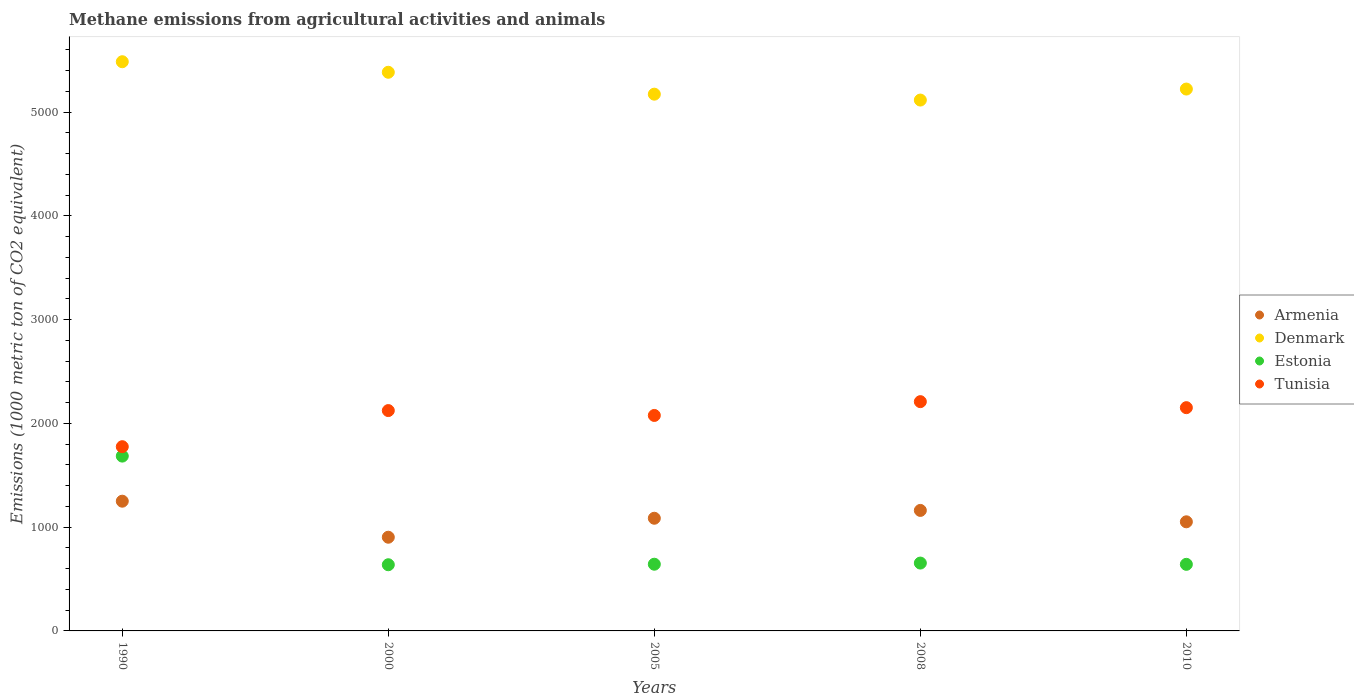How many different coloured dotlines are there?
Give a very brief answer. 4. What is the amount of methane emitted in Estonia in 2005?
Your answer should be very brief. 642.9. Across all years, what is the maximum amount of methane emitted in Armenia?
Your answer should be compact. 1250.4. Across all years, what is the minimum amount of methane emitted in Denmark?
Make the answer very short. 5116.7. What is the total amount of methane emitted in Denmark in the graph?
Provide a short and direct response. 2.64e+04. What is the difference between the amount of methane emitted in Denmark in 1990 and that in 2008?
Keep it short and to the point. 369.5. What is the difference between the amount of methane emitted in Tunisia in 1990 and the amount of methane emitted in Armenia in 2005?
Make the answer very short. 689.7. What is the average amount of methane emitted in Armenia per year?
Keep it short and to the point. 1090.54. In the year 2008, what is the difference between the amount of methane emitted in Armenia and amount of methane emitted in Tunisia?
Your answer should be compact. -1048.3. What is the ratio of the amount of methane emitted in Tunisia in 1990 to that in 2000?
Keep it short and to the point. 0.84. Is the amount of methane emitted in Estonia in 1990 less than that in 2000?
Keep it short and to the point. No. What is the difference between the highest and the second highest amount of methane emitted in Estonia?
Make the answer very short. 1031. What is the difference between the highest and the lowest amount of methane emitted in Estonia?
Give a very brief answer. 1047.1. Is the sum of the amount of methane emitted in Estonia in 2000 and 2008 greater than the maximum amount of methane emitted in Armenia across all years?
Your response must be concise. Yes. Does the amount of methane emitted in Tunisia monotonically increase over the years?
Ensure brevity in your answer.  No. Is the amount of methane emitted in Armenia strictly less than the amount of methane emitted in Estonia over the years?
Your answer should be compact. No. How many dotlines are there?
Your answer should be very brief. 4. What is the difference between two consecutive major ticks on the Y-axis?
Keep it short and to the point. 1000. Does the graph contain any zero values?
Make the answer very short. No. Where does the legend appear in the graph?
Offer a terse response. Center right. What is the title of the graph?
Your answer should be very brief. Methane emissions from agricultural activities and animals. What is the label or title of the Y-axis?
Your response must be concise. Emissions (1000 metric ton of CO2 equivalent). What is the Emissions (1000 metric ton of CO2 equivalent) in Armenia in 1990?
Your response must be concise. 1250.4. What is the Emissions (1000 metric ton of CO2 equivalent) in Denmark in 1990?
Provide a short and direct response. 5486.2. What is the Emissions (1000 metric ton of CO2 equivalent) of Estonia in 1990?
Your response must be concise. 1685. What is the Emissions (1000 metric ton of CO2 equivalent) in Tunisia in 1990?
Offer a terse response. 1775.7. What is the Emissions (1000 metric ton of CO2 equivalent) of Armenia in 2000?
Keep it short and to the point. 903.1. What is the Emissions (1000 metric ton of CO2 equivalent) of Denmark in 2000?
Your response must be concise. 5384.6. What is the Emissions (1000 metric ton of CO2 equivalent) in Estonia in 2000?
Your answer should be very brief. 637.9. What is the Emissions (1000 metric ton of CO2 equivalent) in Tunisia in 2000?
Your answer should be very brief. 2123.8. What is the Emissions (1000 metric ton of CO2 equivalent) of Armenia in 2005?
Keep it short and to the point. 1086. What is the Emissions (1000 metric ton of CO2 equivalent) in Denmark in 2005?
Offer a very short reply. 5173.5. What is the Emissions (1000 metric ton of CO2 equivalent) in Estonia in 2005?
Your answer should be very brief. 642.9. What is the Emissions (1000 metric ton of CO2 equivalent) in Tunisia in 2005?
Keep it short and to the point. 2076.8. What is the Emissions (1000 metric ton of CO2 equivalent) of Armenia in 2008?
Offer a terse response. 1161.5. What is the Emissions (1000 metric ton of CO2 equivalent) of Denmark in 2008?
Ensure brevity in your answer.  5116.7. What is the Emissions (1000 metric ton of CO2 equivalent) of Estonia in 2008?
Make the answer very short. 654. What is the Emissions (1000 metric ton of CO2 equivalent) in Tunisia in 2008?
Your response must be concise. 2209.8. What is the Emissions (1000 metric ton of CO2 equivalent) of Armenia in 2010?
Your answer should be compact. 1051.7. What is the Emissions (1000 metric ton of CO2 equivalent) in Denmark in 2010?
Provide a short and direct response. 5222.8. What is the Emissions (1000 metric ton of CO2 equivalent) of Estonia in 2010?
Your answer should be compact. 641.8. What is the Emissions (1000 metric ton of CO2 equivalent) in Tunisia in 2010?
Offer a terse response. 2151.9. Across all years, what is the maximum Emissions (1000 metric ton of CO2 equivalent) of Armenia?
Offer a very short reply. 1250.4. Across all years, what is the maximum Emissions (1000 metric ton of CO2 equivalent) in Denmark?
Your answer should be very brief. 5486.2. Across all years, what is the maximum Emissions (1000 metric ton of CO2 equivalent) of Estonia?
Your response must be concise. 1685. Across all years, what is the maximum Emissions (1000 metric ton of CO2 equivalent) of Tunisia?
Offer a very short reply. 2209.8. Across all years, what is the minimum Emissions (1000 metric ton of CO2 equivalent) in Armenia?
Your answer should be very brief. 903.1. Across all years, what is the minimum Emissions (1000 metric ton of CO2 equivalent) in Denmark?
Your answer should be very brief. 5116.7. Across all years, what is the minimum Emissions (1000 metric ton of CO2 equivalent) of Estonia?
Give a very brief answer. 637.9. Across all years, what is the minimum Emissions (1000 metric ton of CO2 equivalent) in Tunisia?
Your answer should be compact. 1775.7. What is the total Emissions (1000 metric ton of CO2 equivalent) of Armenia in the graph?
Give a very brief answer. 5452.7. What is the total Emissions (1000 metric ton of CO2 equivalent) in Denmark in the graph?
Your answer should be compact. 2.64e+04. What is the total Emissions (1000 metric ton of CO2 equivalent) of Estonia in the graph?
Your response must be concise. 4261.6. What is the total Emissions (1000 metric ton of CO2 equivalent) in Tunisia in the graph?
Offer a terse response. 1.03e+04. What is the difference between the Emissions (1000 metric ton of CO2 equivalent) of Armenia in 1990 and that in 2000?
Offer a terse response. 347.3. What is the difference between the Emissions (1000 metric ton of CO2 equivalent) of Denmark in 1990 and that in 2000?
Provide a succinct answer. 101.6. What is the difference between the Emissions (1000 metric ton of CO2 equivalent) of Estonia in 1990 and that in 2000?
Provide a succinct answer. 1047.1. What is the difference between the Emissions (1000 metric ton of CO2 equivalent) of Tunisia in 1990 and that in 2000?
Your answer should be compact. -348.1. What is the difference between the Emissions (1000 metric ton of CO2 equivalent) of Armenia in 1990 and that in 2005?
Make the answer very short. 164.4. What is the difference between the Emissions (1000 metric ton of CO2 equivalent) of Denmark in 1990 and that in 2005?
Keep it short and to the point. 312.7. What is the difference between the Emissions (1000 metric ton of CO2 equivalent) in Estonia in 1990 and that in 2005?
Make the answer very short. 1042.1. What is the difference between the Emissions (1000 metric ton of CO2 equivalent) of Tunisia in 1990 and that in 2005?
Offer a terse response. -301.1. What is the difference between the Emissions (1000 metric ton of CO2 equivalent) in Armenia in 1990 and that in 2008?
Ensure brevity in your answer.  88.9. What is the difference between the Emissions (1000 metric ton of CO2 equivalent) in Denmark in 1990 and that in 2008?
Your answer should be very brief. 369.5. What is the difference between the Emissions (1000 metric ton of CO2 equivalent) in Estonia in 1990 and that in 2008?
Provide a succinct answer. 1031. What is the difference between the Emissions (1000 metric ton of CO2 equivalent) of Tunisia in 1990 and that in 2008?
Give a very brief answer. -434.1. What is the difference between the Emissions (1000 metric ton of CO2 equivalent) of Armenia in 1990 and that in 2010?
Provide a succinct answer. 198.7. What is the difference between the Emissions (1000 metric ton of CO2 equivalent) of Denmark in 1990 and that in 2010?
Offer a terse response. 263.4. What is the difference between the Emissions (1000 metric ton of CO2 equivalent) of Estonia in 1990 and that in 2010?
Ensure brevity in your answer.  1043.2. What is the difference between the Emissions (1000 metric ton of CO2 equivalent) in Tunisia in 1990 and that in 2010?
Your response must be concise. -376.2. What is the difference between the Emissions (1000 metric ton of CO2 equivalent) of Armenia in 2000 and that in 2005?
Provide a succinct answer. -182.9. What is the difference between the Emissions (1000 metric ton of CO2 equivalent) of Denmark in 2000 and that in 2005?
Make the answer very short. 211.1. What is the difference between the Emissions (1000 metric ton of CO2 equivalent) of Estonia in 2000 and that in 2005?
Keep it short and to the point. -5. What is the difference between the Emissions (1000 metric ton of CO2 equivalent) of Armenia in 2000 and that in 2008?
Provide a short and direct response. -258.4. What is the difference between the Emissions (1000 metric ton of CO2 equivalent) in Denmark in 2000 and that in 2008?
Your answer should be very brief. 267.9. What is the difference between the Emissions (1000 metric ton of CO2 equivalent) of Estonia in 2000 and that in 2008?
Your response must be concise. -16.1. What is the difference between the Emissions (1000 metric ton of CO2 equivalent) of Tunisia in 2000 and that in 2008?
Make the answer very short. -86. What is the difference between the Emissions (1000 metric ton of CO2 equivalent) of Armenia in 2000 and that in 2010?
Give a very brief answer. -148.6. What is the difference between the Emissions (1000 metric ton of CO2 equivalent) in Denmark in 2000 and that in 2010?
Make the answer very short. 161.8. What is the difference between the Emissions (1000 metric ton of CO2 equivalent) in Tunisia in 2000 and that in 2010?
Offer a terse response. -28.1. What is the difference between the Emissions (1000 metric ton of CO2 equivalent) of Armenia in 2005 and that in 2008?
Offer a very short reply. -75.5. What is the difference between the Emissions (1000 metric ton of CO2 equivalent) of Denmark in 2005 and that in 2008?
Offer a very short reply. 56.8. What is the difference between the Emissions (1000 metric ton of CO2 equivalent) of Tunisia in 2005 and that in 2008?
Your answer should be very brief. -133. What is the difference between the Emissions (1000 metric ton of CO2 equivalent) in Armenia in 2005 and that in 2010?
Give a very brief answer. 34.3. What is the difference between the Emissions (1000 metric ton of CO2 equivalent) of Denmark in 2005 and that in 2010?
Your answer should be compact. -49.3. What is the difference between the Emissions (1000 metric ton of CO2 equivalent) of Estonia in 2005 and that in 2010?
Your answer should be very brief. 1.1. What is the difference between the Emissions (1000 metric ton of CO2 equivalent) of Tunisia in 2005 and that in 2010?
Give a very brief answer. -75.1. What is the difference between the Emissions (1000 metric ton of CO2 equivalent) of Armenia in 2008 and that in 2010?
Your answer should be very brief. 109.8. What is the difference between the Emissions (1000 metric ton of CO2 equivalent) of Denmark in 2008 and that in 2010?
Your answer should be very brief. -106.1. What is the difference between the Emissions (1000 metric ton of CO2 equivalent) in Tunisia in 2008 and that in 2010?
Ensure brevity in your answer.  57.9. What is the difference between the Emissions (1000 metric ton of CO2 equivalent) in Armenia in 1990 and the Emissions (1000 metric ton of CO2 equivalent) in Denmark in 2000?
Your response must be concise. -4134.2. What is the difference between the Emissions (1000 metric ton of CO2 equivalent) in Armenia in 1990 and the Emissions (1000 metric ton of CO2 equivalent) in Estonia in 2000?
Make the answer very short. 612.5. What is the difference between the Emissions (1000 metric ton of CO2 equivalent) of Armenia in 1990 and the Emissions (1000 metric ton of CO2 equivalent) of Tunisia in 2000?
Your answer should be very brief. -873.4. What is the difference between the Emissions (1000 metric ton of CO2 equivalent) of Denmark in 1990 and the Emissions (1000 metric ton of CO2 equivalent) of Estonia in 2000?
Provide a short and direct response. 4848.3. What is the difference between the Emissions (1000 metric ton of CO2 equivalent) of Denmark in 1990 and the Emissions (1000 metric ton of CO2 equivalent) of Tunisia in 2000?
Provide a short and direct response. 3362.4. What is the difference between the Emissions (1000 metric ton of CO2 equivalent) of Estonia in 1990 and the Emissions (1000 metric ton of CO2 equivalent) of Tunisia in 2000?
Your answer should be very brief. -438.8. What is the difference between the Emissions (1000 metric ton of CO2 equivalent) in Armenia in 1990 and the Emissions (1000 metric ton of CO2 equivalent) in Denmark in 2005?
Provide a short and direct response. -3923.1. What is the difference between the Emissions (1000 metric ton of CO2 equivalent) of Armenia in 1990 and the Emissions (1000 metric ton of CO2 equivalent) of Estonia in 2005?
Your answer should be very brief. 607.5. What is the difference between the Emissions (1000 metric ton of CO2 equivalent) of Armenia in 1990 and the Emissions (1000 metric ton of CO2 equivalent) of Tunisia in 2005?
Your response must be concise. -826.4. What is the difference between the Emissions (1000 metric ton of CO2 equivalent) in Denmark in 1990 and the Emissions (1000 metric ton of CO2 equivalent) in Estonia in 2005?
Give a very brief answer. 4843.3. What is the difference between the Emissions (1000 metric ton of CO2 equivalent) of Denmark in 1990 and the Emissions (1000 metric ton of CO2 equivalent) of Tunisia in 2005?
Offer a very short reply. 3409.4. What is the difference between the Emissions (1000 metric ton of CO2 equivalent) in Estonia in 1990 and the Emissions (1000 metric ton of CO2 equivalent) in Tunisia in 2005?
Your answer should be very brief. -391.8. What is the difference between the Emissions (1000 metric ton of CO2 equivalent) in Armenia in 1990 and the Emissions (1000 metric ton of CO2 equivalent) in Denmark in 2008?
Keep it short and to the point. -3866.3. What is the difference between the Emissions (1000 metric ton of CO2 equivalent) in Armenia in 1990 and the Emissions (1000 metric ton of CO2 equivalent) in Estonia in 2008?
Your answer should be compact. 596.4. What is the difference between the Emissions (1000 metric ton of CO2 equivalent) of Armenia in 1990 and the Emissions (1000 metric ton of CO2 equivalent) of Tunisia in 2008?
Provide a succinct answer. -959.4. What is the difference between the Emissions (1000 metric ton of CO2 equivalent) of Denmark in 1990 and the Emissions (1000 metric ton of CO2 equivalent) of Estonia in 2008?
Ensure brevity in your answer.  4832.2. What is the difference between the Emissions (1000 metric ton of CO2 equivalent) of Denmark in 1990 and the Emissions (1000 metric ton of CO2 equivalent) of Tunisia in 2008?
Provide a succinct answer. 3276.4. What is the difference between the Emissions (1000 metric ton of CO2 equivalent) in Estonia in 1990 and the Emissions (1000 metric ton of CO2 equivalent) in Tunisia in 2008?
Make the answer very short. -524.8. What is the difference between the Emissions (1000 metric ton of CO2 equivalent) in Armenia in 1990 and the Emissions (1000 metric ton of CO2 equivalent) in Denmark in 2010?
Make the answer very short. -3972.4. What is the difference between the Emissions (1000 metric ton of CO2 equivalent) in Armenia in 1990 and the Emissions (1000 metric ton of CO2 equivalent) in Estonia in 2010?
Your answer should be very brief. 608.6. What is the difference between the Emissions (1000 metric ton of CO2 equivalent) in Armenia in 1990 and the Emissions (1000 metric ton of CO2 equivalent) in Tunisia in 2010?
Provide a short and direct response. -901.5. What is the difference between the Emissions (1000 metric ton of CO2 equivalent) of Denmark in 1990 and the Emissions (1000 metric ton of CO2 equivalent) of Estonia in 2010?
Offer a terse response. 4844.4. What is the difference between the Emissions (1000 metric ton of CO2 equivalent) of Denmark in 1990 and the Emissions (1000 metric ton of CO2 equivalent) of Tunisia in 2010?
Your answer should be compact. 3334.3. What is the difference between the Emissions (1000 metric ton of CO2 equivalent) in Estonia in 1990 and the Emissions (1000 metric ton of CO2 equivalent) in Tunisia in 2010?
Make the answer very short. -466.9. What is the difference between the Emissions (1000 metric ton of CO2 equivalent) in Armenia in 2000 and the Emissions (1000 metric ton of CO2 equivalent) in Denmark in 2005?
Ensure brevity in your answer.  -4270.4. What is the difference between the Emissions (1000 metric ton of CO2 equivalent) in Armenia in 2000 and the Emissions (1000 metric ton of CO2 equivalent) in Estonia in 2005?
Make the answer very short. 260.2. What is the difference between the Emissions (1000 metric ton of CO2 equivalent) of Armenia in 2000 and the Emissions (1000 metric ton of CO2 equivalent) of Tunisia in 2005?
Your response must be concise. -1173.7. What is the difference between the Emissions (1000 metric ton of CO2 equivalent) of Denmark in 2000 and the Emissions (1000 metric ton of CO2 equivalent) of Estonia in 2005?
Your answer should be very brief. 4741.7. What is the difference between the Emissions (1000 metric ton of CO2 equivalent) of Denmark in 2000 and the Emissions (1000 metric ton of CO2 equivalent) of Tunisia in 2005?
Your answer should be compact. 3307.8. What is the difference between the Emissions (1000 metric ton of CO2 equivalent) of Estonia in 2000 and the Emissions (1000 metric ton of CO2 equivalent) of Tunisia in 2005?
Make the answer very short. -1438.9. What is the difference between the Emissions (1000 metric ton of CO2 equivalent) of Armenia in 2000 and the Emissions (1000 metric ton of CO2 equivalent) of Denmark in 2008?
Offer a very short reply. -4213.6. What is the difference between the Emissions (1000 metric ton of CO2 equivalent) in Armenia in 2000 and the Emissions (1000 metric ton of CO2 equivalent) in Estonia in 2008?
Offer a very short reply. 249.1. What is the difference between the Emissions (1000 metric ton of CO2 equivalent) of Armenia in 2000 and the Emissions (1000 metric ton of CO2 equivalent) of Tunisia in 2008?
Your response must be concise. -1306.7. What is the difference between the Emissions (1000 metric ton of CO2 equivalent) of Denmark in 2000 and the Emissions (1000 metric ton of CO2 equivalent) of Estonia in 2008?
Offer a terse response. 4730.6. What is the difference between the Emissions (1000 metric ton of CO2 equivalent) of Denmark in 2000 and the Emissions (1000 metric ton of CO2 equivalent) of Tunisia in 2008?
Ensure brevity in your answer.  3174.8. What is the difference between the Emissions (1000 metric ton of CO2 equivalent) of Estonia in 2000 and the Emissions (1000 metric ton of CO2 equivalent) of Tunisia in 2008?
Ensure brevity in your answer.  -1571.9. What is the difference between the Emissions (1000 metric ton of CO2 equivalent) in Armenia in 2000 and the Emissions (1000 metric ton of CO2 equivalent) in Denmark in 2010?
Ensure brevity in your answer.  -4319.7. What is the difference between the Emissions (1000 metric ton of CO2 equivalent) in Armenia in 2000 and the Emissions (1000 metric ton of CO2 equivalent) in Estonia in 2010?
Make the answer very short. 261.3. What is the difference between the Emissions (1000 metric ton of CO2 equivalent) of Armenia in 2000 and the Emissions (1000 metric ton of CO2 equivalent) of Tunisia in 2010?
Provide a succinct answer. -1248.8. What is the difference between the Emissions (1000 metric ton of CO2 equivalent) of Denmark in 2000 and the Emissions (1000 metric ton of CO2 equivalent) of Estonia in 2010?
Make the answer very short. 4742.8. What is the difference between the Emissions (1000 metric ton of CO2 equivalent) in Denmark in 2000 and the Emissions (1000 metric ton of CO2 equivalent) in Tunisia in 2010?
Ensure brevity in your answer.  3232.7. What is the difference between the Emissions (1000 metric ton of CO2 equivalent) of Estonia in 2000 and the Emissions (1000 metric ton of CO2 equivalent) of Tunisia in 2010?
Provide a succinct answer. -1514. What is the difference between the Emissions (1000 metric ton of CO2 equivalent) of Armenia in 2005 and the Emissions (1000 metric ton of CO2 equivalent) of Denmark in 2008?
Ensure brevity in your answer.  -4030.7. What is the difference between the Emissions (1000 metric ton of CO2 equivalent) in Armenia in 2005 and the Emissions (1000 metric ton of CO2 equivalent) in Estonia in 2008?
Make the answer very short. 432. What is the difference between the Emissions (1000 metric ton of CO2 equivalent) in Armenia in 2005 and the Emissions (1000 metric ton of CO2 equivalent) in Tunisia in 2008?
Your answer should be compact. -1123.8. What is the difference between the Emissions (1000 metric ton of CO2 equivalent) in Denmark in 2005 and the Emissions (1000 metric ton of CO2 equivalent) in Estonia in 2008?
Your answer should be very brief. 4519.5. What is the difference between the Emissions (1000 metric ton of CO2 equivalent) in Denmark in 2005 and the Emissions (1000 metric ton of CO2 equivalent) in Tunisia in 2008?
Provide a short and direct response. 2963.7. What is the difference between the Emissions (1000 metric ton of CO2 equivalent) of Estonia in 2005 and the Emissions (1000 metric ton of CO2 equivalent) of Tunisia in 2008?
Ensure brevity in your answer.  -1566.9. What is the difference between the Emissions (1000 metric ton of CO2 equivalent) in Armenia in 2005 and the Emissions (1000 metric ton of CO2 equivalent) in Denmark in 2010?
Provide a succinct answer. -4136.8. What is the difference between the Emissions (1000 metric ton of CO2 equivalent) in Armenia in 2005 and the Emissions (1000 metric ton of CO2 equivalent) in Estonia in 2010?
Ensure brevity in your answer.  444.2. What is the difference between the Emissions (1000 metric ton of CO2 equivalent) in Armenia in 2005 and the Emissions (1000 metric ton of CO2 equivalent) in Tunisia in 2010?
Provide a succinct answer. -1065.9. What is the difference between the Emissions (1000 metric ton of CO2 equivalent) of Denmark in 2005 and the Emissions (1000 metric ton of CO2 equivalent) of Estonia in 2010?
Your answer should be very brief. 4531.7. What is the difference between the Emissions (1000 metric ton of CO2 equivalent) in Denmark in 2005 and the Emissions (1000 metric ton of CO2 equivalent) in Tunisia in 2010?
Provide a succinct answer. 3021.6. What is the difference between the Emissions (1000 metric ton of CO2 equivalent) of Estonia in 2005 and the Emissions (1000 metric ton of CO2 equivalent) of Tunisia in 2010?
Ensure brevity in your answer.  -1509. What is the difference between the Emissions (1000 metric ton of CO2 equivalent) in Armenia in 2008 and the Emissions (1000 metric ton of CO2 equivalent) in Denmark in 2010?
Keep it short and to the point. -4061.3. What is the difference between the Emissions (1000 metric ton of CO2 equivalent) of Armenia in 2008 and the Emissions (1000 metric ton of CO2 equivalent) of Estonia in 2010?
Your answer should be compact. 519.7. What is the difference between the Emissions (1000 metric ton of CO2 equivalent) in Armenia in 2008 and the Emissions (1000 metric ton of CO2 equivalent) in Tunisia in 2010?
Your answer should be compact. -990.4. What is the difference between the Emissions (1000 metric ton of CO2 equivalent) in Denmark in 2008 and the Emissions (1000 metric ton of CO2 equivalent) in Estonia in 2010?
Offer a very short reply. 4474.9. What is the difference between the Emissions (1000 metric ton of CO2 equivalent) in Denmark in 2008 and the Emissions (1000 metric ton of CO2 equivalent) in Tunisia in 2010?
Offer a very short reply. 2964.8. What is the difference between the Emissions (1000 metric ton of CO2 equivalent) in Estonia in 2008 and the Emissions (1000 metric ton of CO2 equivalent) in Tunisia in 2010?
Your answer should be very brief. -1497.9. What is the average Emissions (1000 metric ton of CO2 equivalent) in Armenia per year?
Provide a succinct answer. 1090.54. What is the average Emissions (1000 metric ton of CO2 equivalent) of Denmark per year?
Provide a succinct answer. 5276.76. What is the average Emissions (1000 metric ton of CO2 equivalent) of Estonia per year?
Provide a succinct answer. 852.32. What is the average Emissions (1000 metric ton of CO2 equivalent) of Tunisia per year?
Provide a short and direct response. 2067.6. In the year 1990, what is the difference between the Emissions (1000 metric ton of CO2 equivalent) in Armenia and Emissions (1000 metric ton of CO2 equivalent) in Denmark?
Offer a very short reply. -4235.8. In the year 1990, what is the difference between the Emissions (1000 metric ton of CO2 equivalent) in Armenia and Emissions (1000 metric ton of CO2 equivalent) in Estonia?
Your response must be concise. -434.6. In the year 1990, what is the difference between the Emissions (1000 metric ton of CO2 equivalent) of Armenia and Emissions (1000 metric ton of CO2 equivalent) of Tunisia?
Ensure brevity in your answer.  -525.3. In the year 1990, what is the difference between the Emissions (1000 metric ton of CO2 equivalent) of Denmark and Emissions (1000 metric ton of CO2 equivalent) of Estonia?
Offer a very short reply. 3801.2. In the year 1990, what is the difference between the Emissions (1000 metric ton of CO2 equivalent) of Denmark and Emissions (1000 metric ton of CO2 equivalent) of Tunisia?
Your answer should be very brief. 3710.5. In the year 1990, what is the difference between the Emissions (1000 metric ton of CO2 equivalent) of Estonia and Emissions (1000 metric ton of CO2 equivalent) of Tunisia?
Give a very brief answer. -90.7. In the year 2000, what is the difference between the Emissions (1000 metric ton of CO2 equivalent) of Armenia and Emissions (1000 metric ton of CO2 equivalent) of Denmark?
Your answer should be very brief. -4481.5. In the year 2000, what is the difference between the Emissions (1000 metric ton of CO2 equivalent) of Armenia and Emissions (1000 metric ton of CO2 equivalent) of Estonia?
Give a very brief answer. 265.2. In the year 2000, what is the difference between the Emissions (1000 metric ton of CO2 equivalent) in Armenia and Emissions (1000 metric ton of CO2 equivalent) in Tunisia?
Ensure brevity in your answer.  -1220.7. In the year 2000, what is the difference between the Emissions (1000 metric ton of CO2 equivalent) of Denmark and Emissions (1000 metric ton of CO2 equivalent) of Estonia?
Offer a terse response. 4746.7. In the year 2000, what is the difference between the Emissions (1000 metric ton of CO2 equivalent) in Denmark and Emissions (1000 metric ton of CO2 equivalent) in Tunisia?
Ensure brevity in your answer.  3260.8. In the year 2000, what is the difference between the Emissions (1000 metric ton of CO2 equivalent) in Estonia and Emissions (1000 metric ton of CO2 equivalent) in Tunisia?
Make the answer very short. -1485.9. In the year 2005, what is the difference between the Emissions (1000 metric ton of CO2 equivalent) of Armenia and Emissions (1000 metric ton of CO2 equivalent) of Denmark?
Keep it short and to the point. -4087.5. In the year 2005, what is the difference between the Emissions (1000 metric ton of CO2 equivalent) of Armenia and Emissions (1000 metric ton of CO2 equivalent) of Estonia?
Make the answer very short. 443.1. In the year 2005, what is the difference between the Emissions (1000 metric ton of CO2 equivalent) in Armenia and Emissions (1000 metric ton of CO2 equivalent) in Tunisia?
Provide a short and direct response. -990.8. In the year 2005, what is the difference between the Emissions (1000 metric ton of CO2 equivalent) of Denmark and Emissions (1000 metric ton of CO2 equivalent) of Estonia?
Your response must be concise. 4530.6. In the year 2005, what is the difference between the Emissions (1000 metric ton of CO2 equivalent) in Denmark and Emissions (1000 metric ton of CO2 equivalent) in Tunisia?
Your answer should be very brief. 3096.7. In the year 2005, what is the difference between the Emissions (1000 metric ton of CO2 equivalent) in Estonia and Emissions (1000 metric ton of CO2 equivalent) in Tunisia?
Ensure brevity in your answer.  -1433.9. In the year 2008, what is the difference between the Emissions (1000 metric ton of CO2 equivalent) of Armenia and Emissions (1000 metric ton of CO2 equivalent) of Denmark?
Give a very brief answer. -3955.2. In the year 2008, what is the difference between the Emissions (1000 metric ton of CO2 equivalent) of Armenia and Emissions (1000 metric ton of CO2 equivalent) of Estonia?
Offer a terse response. 507.5. In the year 2008, what is the difference between the Emissions (1000 metric ton of CO2 equivalent) in Armenia and Emissions (1000 metric ton of CO2 equivalent) in Tunisia?
Give a very brief answer. -1048.3. In the year 2008, what is the difference between the Emissions (1000 metric ton of CO2 equivalent) of Denmark and Emissions (1000 metric ton of CO2 equivalent) of Estonia?
Keep it short and to the point. 4462.7. In the year 2008, what is the difference between the Emissions (1000 metric ton of CO2 equivalent) in Denmark and Emissions (1000 metric ton of CO2 equivalent) in Tunisia?
Offer a terse response. 2906.9. In the year 2008, what is the difference between the Emissions (1000 metric ton of CO2 equivalent) of Estonia and Emissions (1000 metric ton of CO2 equivalent) of Tunisia?
Ensure brevity in your answer.  -1555.8. In the year 2010, what is the difference between the Emissions (1000 metric ton of CO2 equivalent) in Armenia and Emissions (1000 metric ton of CO2 equivalent) in Denmark?
Provide a short and direct response. -4171.1. In the year 2010, what is the difference between the Emissions (1000 metric ton of CO2 equivalent) in Armenia and Emissions (1000 metric ton of CO2 equivalent) in Estonia?
Make the answer very short. 409.9. In the year 2010, what is the difference between the Emissions (1000 metric ton of CO2 equivalent) of Armenia and Emissions (1000 metric ton of CO2 equivalent) of Tunisia?
Ensure brevity in your answer.  -1100.2. In the year 2010, what is the difference between the Emissions (1000 metric ton of CO2 equivalent) of Denmark and Emissions (1000 metric ton of CO2 equivalent) of Estonia?
Ensure brevity in your answer.  4581. In the year 2010, what is the difference between the Emissions (1000 metric ton of CO2 equivalent) of Denmark and Emissions (1000 metric ton of CO2 equivalent) of Tunisia?
Ensure brevity in your answer.  3070.9. In the year 2010, what is the difference between the Emissions (1000 metric ton of CO2 equivalent) of Estonia and Emissions (1000 metric ton of CO2 equivalent) of Tunisia?
Give a very brief answer. -1510.1. What is the ratio of the Emissions (1000 metric ton of CO2 equivalent) of Armenia in 1990 to that in 2000?
Make the answer very short. 1.38. What is the ratio of the Emissions (1000 metric ton of CO2 equivalent) of Denmark in 1990 to that in 2000?
Your response must be concise. 1.02. What is the ratio of the Emissions (1000 metric ton of CO2 equivalent) in Estonia in 1990 to that in 2000?
Your answer should be very brief. 2.64. What is the ratio of the Emissions (1000 metric ton of CO2 equivalent) of Tunisia in 1990 to that in 2000?
Keep it short and to the point. 0.84. What is the ratio of the Emissions (1000 metric ton of CO2 equivalent) of Armenia in 1990 to that in 2005?
Your response must be concise. 1.15. What is the ratio of the Emissions (1000 metric ton of CO2 equivalent) of Denmark in 1990 to that in 2005?
Offer a terse response. 1.06. What is the ratio of the Emissions (1000 metric ton of CO2 equivalent) in Estonia in 1990 to that in 2005?
Give a very brief answer. 2.62. What is the ratio of the Emissions (1000 metric ton of CO2 equivalent) in Tunisia in 1990 to that in 2005?
Give a very brief answer. 0.85. What is the ratio of the Emissions (1000 metric ton of CO2 equivalent) in Armenia in 1990 to that in 2008?
Give a very brief answer. 1.08. What is the ratio of the Emissions (1000 metric ton of CO2 equivalent) in Denmark in 1990 to that in 2008?
Provide a short and direct response. 1.07. What is the ratio of the Emissions (1000 metric ton of CO2 equivalent) of Estonia in 1990 to that in 2008?
Give a very brief answer. 2.58. What is the ratio of the Emissions (1000 metric ton of CO2 equivalent) in Tunisia in 1990 to that in 2008?
Give a very brief answer. 0.8. What is the ratio of the Emissions (1000 metric ton of CO2 equivalent) in Armenia in 1990 to that in 2010?
Offer a very short reply. 1.19. What is the ratio of the Emissions (1000 metric ton of CO2 equivalent) of Denmark in 1990 to that in 2010?
Provide a short and direct response. 1.05. What is the ratio of the Emissions (1000 metric ton of CO2 equivalent) of Estonia in 1990 to that in 2010?
Offer a very short reply. 2.63. What is the ratio of the Emissions (1000 metric ton of CO2 equivalent) of Tunisia in 1990 to that in 2010?
Ensure brevity in your answer.  0.83. What is the ratio of the Emissions (1000 metric ton of CO2 equivalent) of Armenia in 2000 to that in 2005?
Provide a succinct answer. 0.83. What is the ratio of the Emissions (1000 metric ton of CO2 equivalent) of Denmark in 2000 to that in 2005?
Your response must be concise. 1.04. What is the ratio of the Emissions (1000 metric ton of CO2 equivalent) in Tunisia in 2000 to that in 2005?
Provide a short and direct response. 1.02. What is the ratio of the Emissions (1000 metric ton of CO2 equivalent) in Armenia in 2000 to that in 2008?
Offer a terse response. 0.78. What is the ratio of the Emissions (1000 metric ton of CO2 equivalent) in Denmark in 2000 to that in 2008?
Make the answer very short. 1.05. What is the ratio of the Emissions (1000 metric ton of CO2 equivalent) of Estonia in 2000 to that in 2008?
Your answer should be very brief. 0.98. What is the ratio of the Emissions (1000 metric ton of CO2 equivalent) of Tunisia in 2000 to that in 2008?
Provide a short and direct response. 0.96. What is the ratio of the Emissions (1000 metric ton of CO2 equivalent) in Armenia in 2000 to that in 2010?
Offer a terse response. 0.86. What is the ratio of the Emissions (1000 metric ton of CO2 equivalent) of Denmark in 2000 to that in 2010?
Provide a short and direct response. 1.03. What is the ratio of the Emissions (1000 metric ton of CO2 equivalent) in Estonia in 2000 to that in 2010?
Ensure brevity in your answer.  0.99. What is the ratio of the Emissions (1000 metric ton of CO2 equivalent) in Tunisia in 2000 to that in 2010?
Offer a terse response. 0.99. What is the ratio of the Emissions (1000 metric ton of CO2 equivalent) in Armenia in 2005 to that in 2008?
Make the answer very short. 0.94. What is the ratio of the Emissions (1000 metric ton of CO2 equivalent) in Denmark in 2005 to that in 2008?
Provide a succinct answer. 1.01. What is the ratio of the Emissions (1000 metric ton of CO2 equivalent) of Tunisia in 2005 to that in 2008?
Your response must be concise. 0.94. What is the ratio of the Emissions (1000 metric ton of CO2 equivalent) in Armenia in 2005 to that in 2010?
Keep it short and to the point. 1.03. What is the ratio of the Emissions (1000 metric ton of CO2 equivalent) in Denmark in 2005 to that in 2010?
Your answer should be very brief. 0.99. What is the ratio of the Emissions (1000 metric ton of CO2 equivalent) of Tunisia in 2005 to that in 2010?
Provide a short and direct response. 0.97. What is the ratio of the Emissions (1000 metric ton of CO2 equivalent) of Armenia in 2008 to that in 2010?
Your response must be concise. 1.1. What is the ratio of the Emissions (1000 metric ton of CO2 equivalent) in Denmark in 2008 to that in 2010?
Provide a short and direct response. 0.98. What is the ratio of the Emissions (1000 metric ton of CO2 equivalent) of Estonia in 2008 to that in 2010?
Your answer should be very brief. 1.02. What is the ratio of the Emissions (1000 metric ton of CO2 equivalent) of Tunisia in 2008 to that in 2010?
Your answer should be compact. 1.03. What is the difference between the highest and the second highest Emissions (1000 metric ton of CO2 equivalent) in Armenia?
Ensure brevity in your answer.  88.9. What is the difference between the highest and the second highest Emissions (1000 metric ton of CO2 equivalent) in Denmark?
Offer a very short reply. 101.6. What is the difference between the highest and the second highest Emissions (1000 metric ton of CO2 equivalent) in Estonia?
Keep it short and to the point. 1031. What is the difference between the highest and the second highest Emissions (1000 metric ton of CO2 equivalent) of Tunisia?
Your response must be concise. 57.9. What is the difference between the highest and the lowest Emissions (1000 metric ton of CO2 equivalent) of Armenia?
Your answer should be very brief. 347.3. What is the difference between the highest and the lowest Emissions (1000 metric ton of CO2 equivalent) in Denmark?
Make the answer very short. 369.5. What is the difference between the highest and the lowest Emissions (1000 metric ton of CO2 equivalent) of Estonia?
Your answer should be very brief. 1047.1. What is the difference between the highest and the lowest Emissions (1000 metric ton of CO2 equivalent) in Tunisia?
Your answer should be very brief. 434.1. 